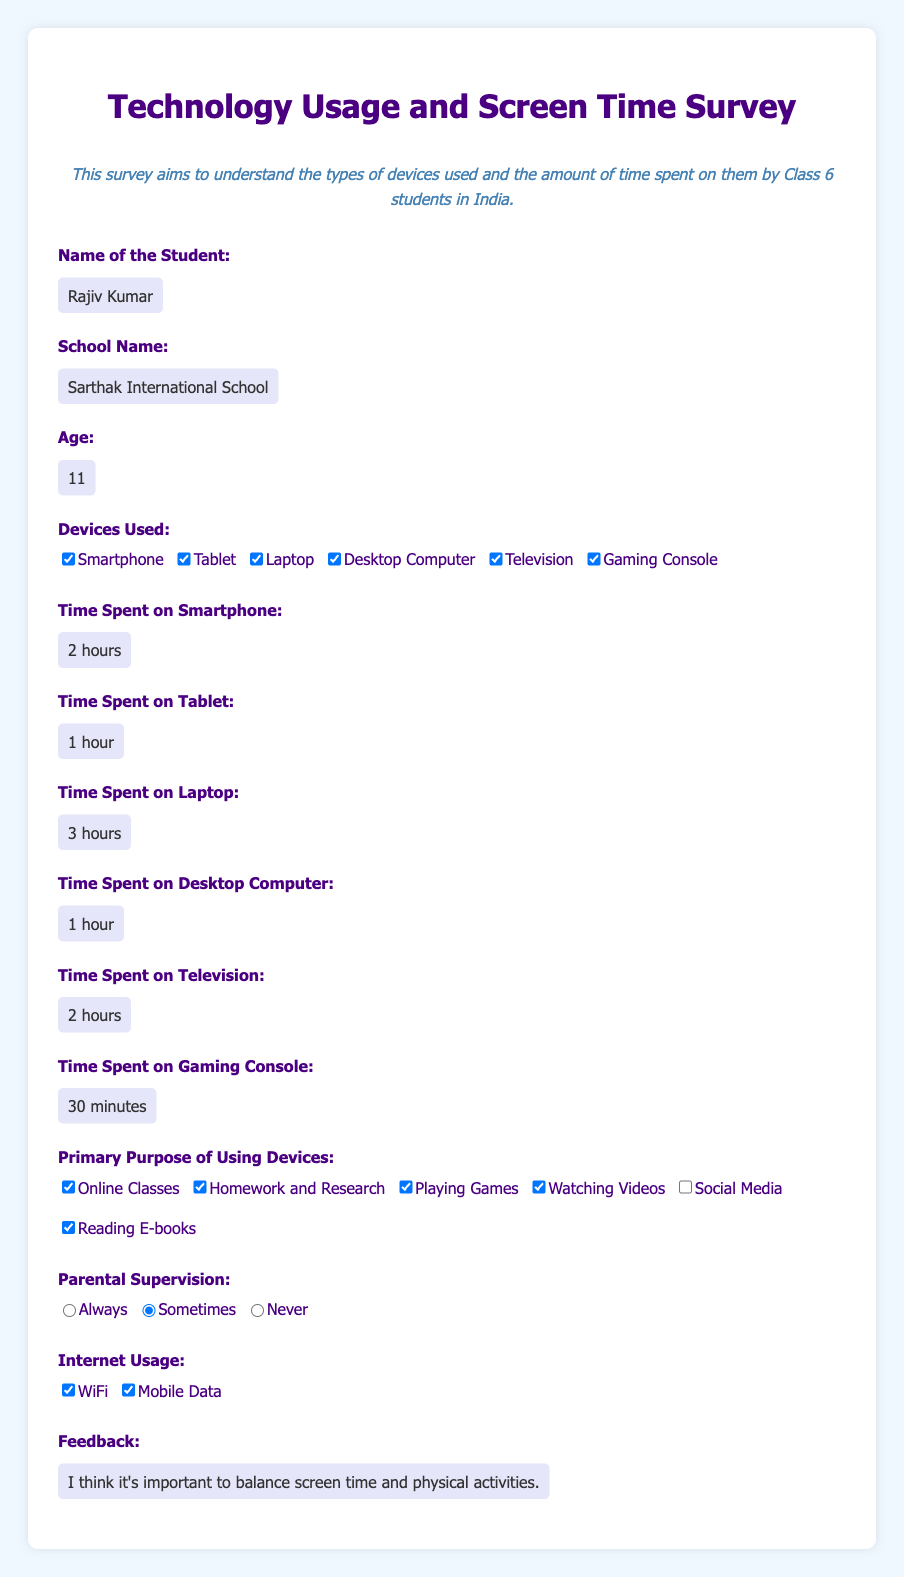What is the name of the student? The document contains the filled value for the student's name.
Answer: Rajiv Kumar How many hours does Rajiv spend on his laptop? The document specifies the amount of time spent on various devices, including the laptop.
Answer: 3 hours Which school does Rajiv attend? The school name is provided in the survey form.
Answer: Sarthak International School What device does Rajiv use for gaming? Gaming is mentioned as one of the purposes of device usage, and it is linked to a specific device type in the form.
Answer: Gaming Console How many minutes does Rajiv spend on his gaming console? The document lists the time spent on each device, including the gaming console.
Answer: 30 minutes What is the primary purpose for using devices according to Rajiv? The document includes a checkbox for different purposes of device usage.
Answer: Online Classes How much time does Rajiv spend watching television? The document mentions the time spent on television specifically.
Answer: 2 hours How often is Rajiv's device usage supervised by parents? There is information about parental supervision provided in the survey.
Answer: Sometimes 